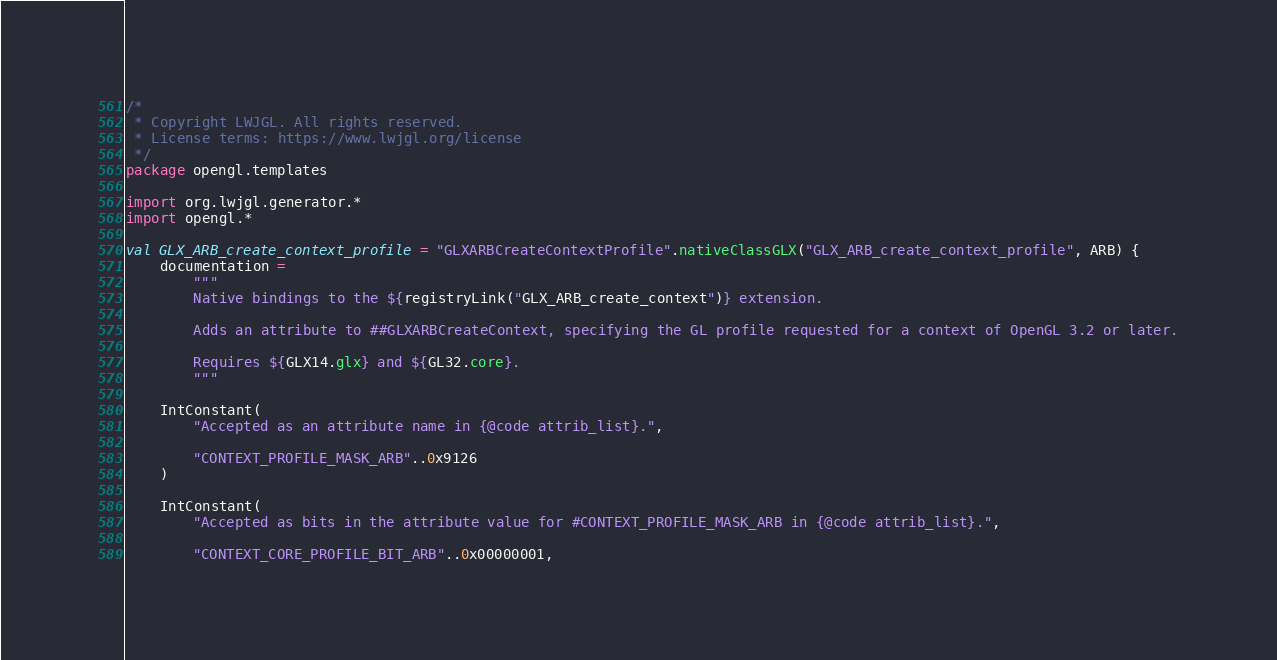<code> <loc_0><loc_0><loc_500><loc_500><_Kotlin_>/*
 * Copyright LWJGL. All rights reserved.
 * License terms: https://www.lwjgl.org/license
 */
package opengl.templates

import org.lwjgl.generator.*
import opengl.*

val GLX_ARB_create_context_profile = "GLXARBCreateContextProfile".nativeClassGLX("GLX_ARB_create_context_profile", ARB) {
    documentation =
        """
        Native bindings to the ${registryLink("GLX_ARB_create_context")} extension.

        Adds an attribute to ##GLXARBCreateContext, specifying the GL profile requested for a context of OpenGL 3.2 or later.

        Requires ${GLX14.glx} and ${GL32.core}.
        """

    IntConstant(
        "Accepted as an attribute name in {@code attrib_list}.",

        "CONTEXT_PROFILE_MASK_ARB"..0x9126
    )

    IntConstant(
        "Accepted as bits in the attribute value for #CONTEXT_PROFILE_MASK_ARB in {@code attrib_list}.",

        "CONTEXT_CORE_PROFILE_BIT_ARB"..0x00000001,</code> 